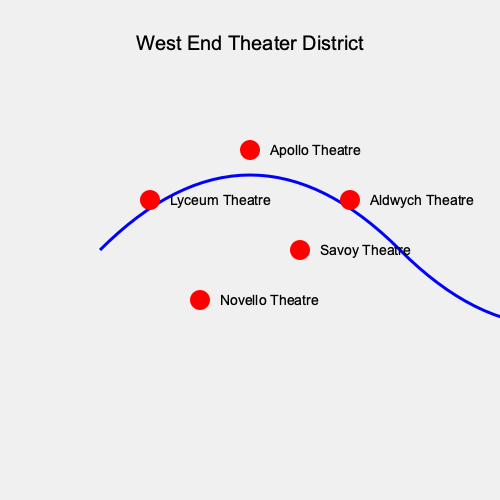Based on the map of West End theaters in London, which theater appears to be located furthest north in the district? To answer this question, we need to analyze the spatial distribution of the theaters on the map:

1. The map shows a curved representation of the West End theater district in London.
2. Five theaters are marked on the map: Lyceum Theatre, Apollo Theatre, Aldwych Theatre, Novello Theatre, and Savoy Theatre.
3. In maps, north is typically represented at the top of the image.
4. Looking at the vertical positioning of the theaters:
   - The Apollo Theatre is positioned highest on the map (y-coordinate of 150).
   - The Lyceum and Aldwych Theatres are at the same height (y-coordinate of 200).
   - The Savoy Theatre is lower (y-coordinate of 250).
   - The Novello Theatre is the lowest (y-coordinate of 300).
5. Since the Apollo Theatre is positioned highest on the map, it represents the northernmost location among the theaters shown.

Therefore, based on this map representation, the Apollo Theatre appears to be located furthest north in the West End theater district.
Answer: Apollo Theatre 